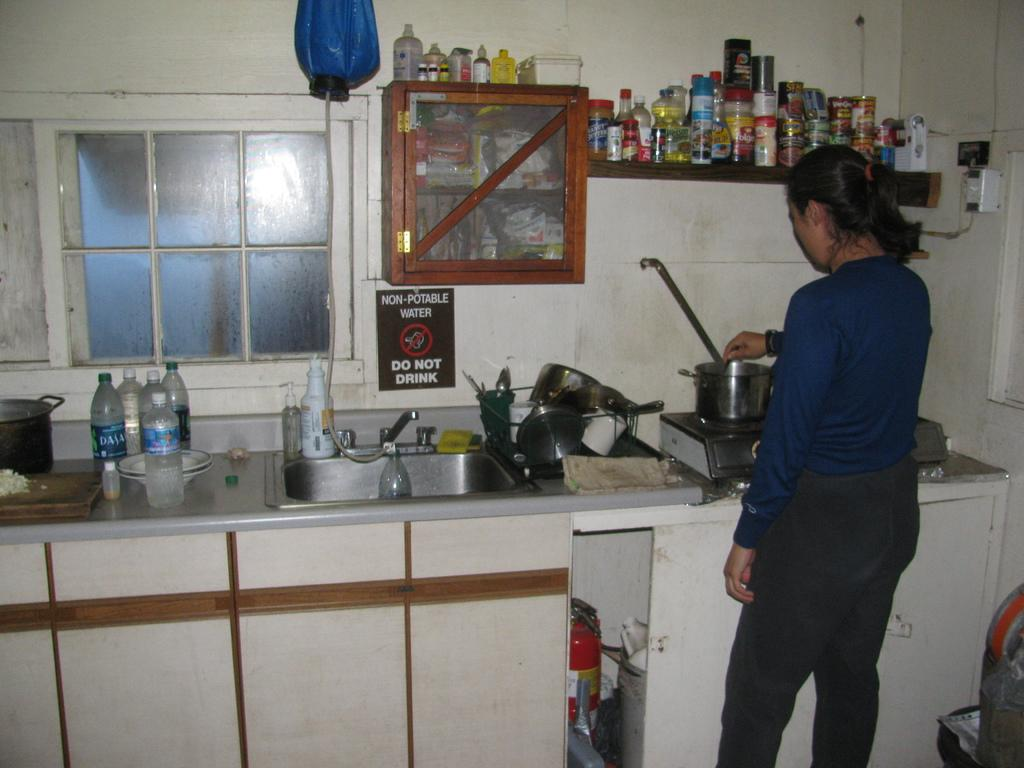Provide a one-sentence caption for the provided image. A woman is cooking in a messy kitchen with a non-portable water sign. 